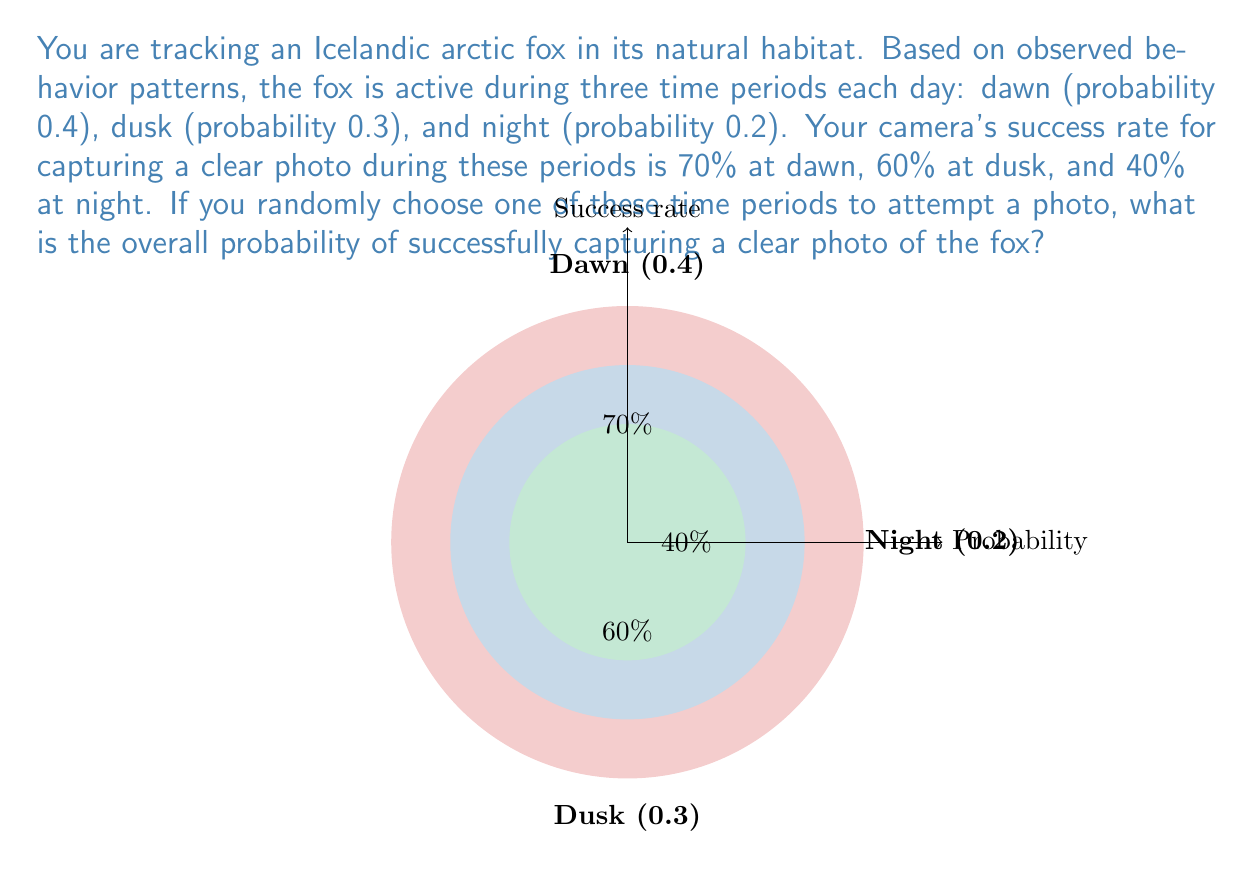Show me your answer to this math problem. To solve this problem, we need to use the law of total probability. Let's break it down step by step:

1) First, let's define our events:
   A = Successfully capturing a clear photo
   D1 = Choosing dawn period
   D2 = Choosing dusk period
   N = Choosing night period

2) We can express the probability of success as:
   $$P(A) = P(A|D1)P(D1) + P(A|D2)P(D2) + P(A|N)P(N)$$

3) Now, let's substitute the given probabilities:
   $$P(A) = 0.7 \cdot 0.4 + 0.6 \cdot 0.3 + 0.4 \cdot 0.2$$

4) Let's calculate each term:
   Dawn: $0.7 \cdot 0.4 = 0.28$
   Dusk: $0.6 \cdot 0.3 = 0.18$
   Night: $0.4 \cdot 0.2 = 0.08$

5) Sum up all terms:
   $$P(A) = 0.28 + 0.18 + 0.08 = 0.54$$

Therefore, the overall probability of successfully capturing a clear photo of the fox is 0.54 or 54%.
Answer: 0.54 